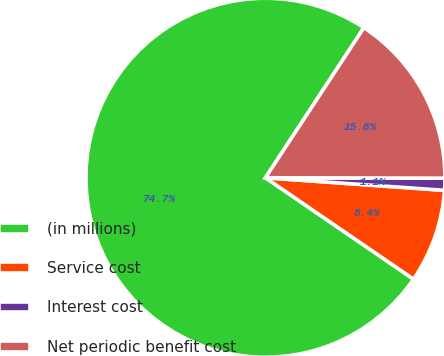<chart> <loc_0><loc_0><loc_500><loc_500><pie_chart><fcel>(in millions)<fcel>Service cost<fcel>Interest cost<fcel>Net periodic benefit cost<nl><fcel>74.69%<fcel>8.44%<fcel>1.08%<fcel>15.8%<nl></chart> 